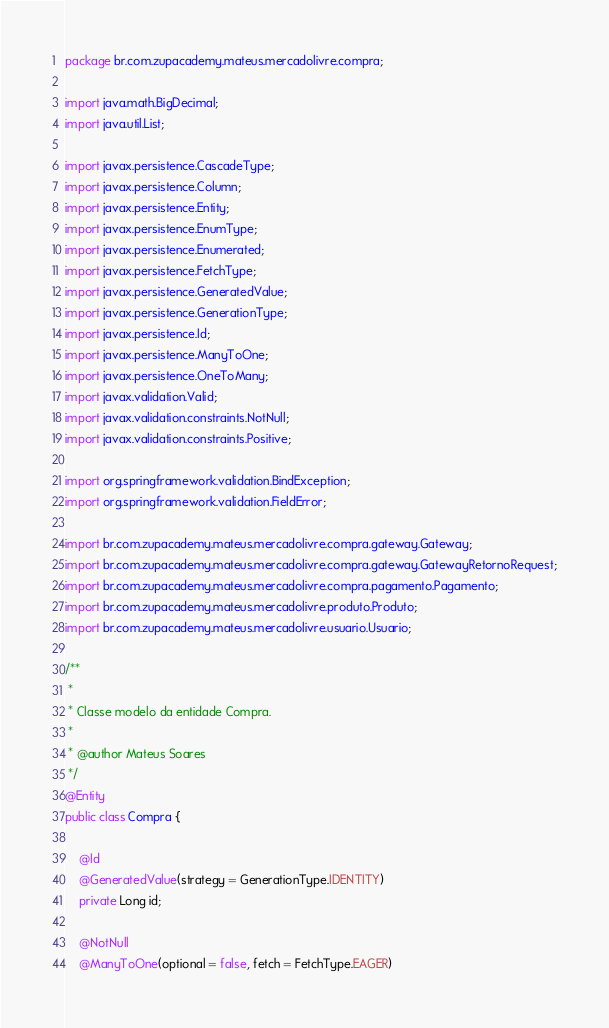<code> <loc_0><loc_0><loc_500><loc_500><_Java_>package br.com.zupacademy.mateus.mercadolivre.compra;

import java.math.BigDecimal;
import java.util.List;

import javax.persistence.CascadeType;
import javax.persistence.Column;
import javax.persistence.Entity;
import javax.persistence.EnumType;
import javax.persistence.Enumerated;
import javax.persistence.FetchType;
import javax.persistence.GeneratedValue;
import javax.persistence.GenerationType;
import javax.persistence.Id;
import javax.persistence.ManyToOne;
import javax.persistence.OneToMany;
import javax.validation.Valid;
import javax.validation.constraints.NotNull;
import javax.validation.constraints.Positive;

import org.springframework.validation.BindException;
import org.springframework.validation.FieldError;

import br.com.zupacademy.mateus.mercadolivre.compra.gateway.Gateway;
import br.com.zupacademy.mateus.mercadolivre.compra.gateway.GatewayRetornoRequest;
import br.com.zupacademy.mateus.mercadolivre.compra.pagamento.Pagamento;
import br.com.zupacademy.mateus.mercadolivre.produto.Produto;
import br.com.zupacademy.mateus.mercadolivre.usuario.Usuario;

/**
 * 
 * Classe modelo da entidade Compra.
 * 
 * @author Mateus Soares
 */
@Entity
public class Compra {

	@Id
	@GeneratedValue(strategy = GenerationType.IDENTITY)
	private Long id;

	@NotNull
	@ManyToOne(optional = false, fetch = FetchType.EAGER)</code> 